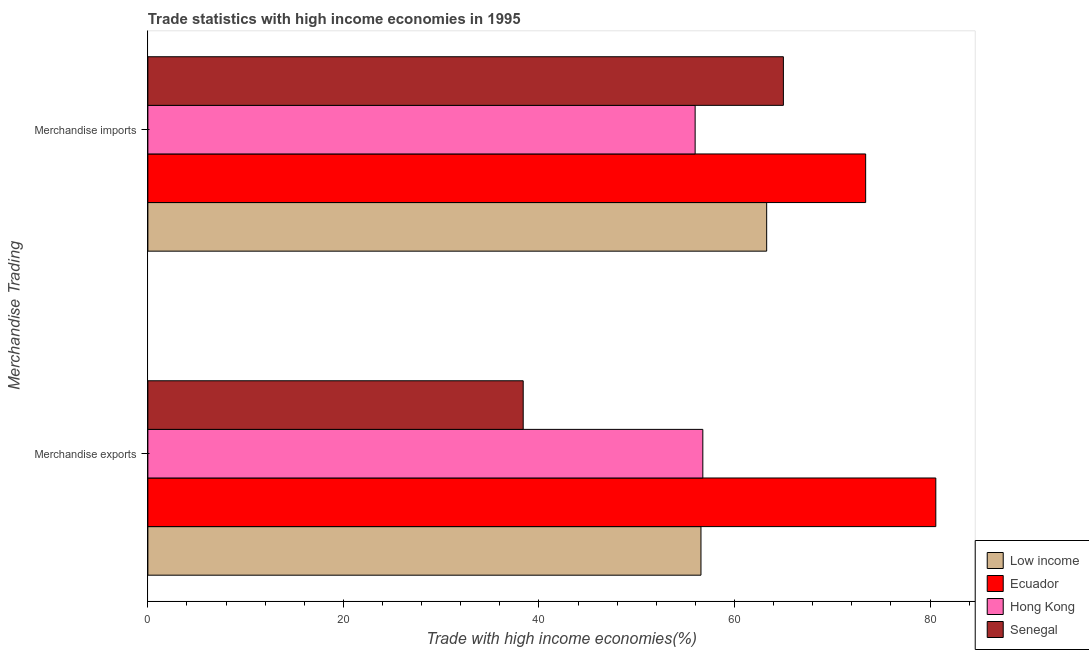How many different coloured bars are there?
Provide a succinct answer. 4. Are the number of bars on each tick of the Y-axis equal?
Keep it short and to the point. Yes. How many bars are there on the 1st tick from the top?
Provide a short and direct response. 4. What is the label of the 2nd group of bars from the top?
Your answer should be very brief. Merchandise exports. What is the merchandise exports in Low income?
Keep it short and to the point. 56.57. Across all countries, what is the maximum merchandise exports?
Offer a terse response. 80.58. Across all countries, what is the minimum merchandise exports?
Keep it short and to the point. 38.39. In which country was the merchandise imports maximum?
Offer a terse response. Ecuador. In which country was the merchandise imports minimum?
Keep it short and to the point. Hong Kong. What is the total merchandise imports in the graph?
Your answer should be compact. 257.66. What is the difference between the merchandise imports in Ecuador and that in Senegal?
Offer a very short reply. 8.41. What is the difference between the merchandise imports in Senegal and the merchandise exports in Ecuador?
Provide a short and direct response. -15.59. What is the average merchandise imports per country?
Your response must be concise. 64.42. What is the difference between the merchandise imports and merchandise exports in Ecuador?
Provide a short and direct response. -7.17. In how many countries, is the merchandise imports greater than 52 %?
Offer a terse response. 4. What is the ratio of the merchandise imports in Hong Kong to that in Low income?
Offer a terse response. 0.88. What does the 2nd bar from the top in Merchandise imports represents?
Offer a very short reply. Hong Kong. What does the 4th bar from the bottom in Merchandise imports represents?
Make the answer very short. Senegal. Are all the bars in the graph horizontal?
Your answer should be compact. Yes. What is the difference between two consecutive major ticks on the X-axis?
Provide a short and direct response. 20. Does the graph contain any zero values?
Offer a very short reply. No. Where does the legend appear in the graph?
Offer a terse response. Bottom right. How many legend labels are there?
Keep it short and to the point. 4. What is the title of the graph?
Provide a succinct answer. Trade statistics with high income economies in 1995. What is the label or title of the X-axis?
Your response must be concise. Trade with high income economies(%). What is the label or title of the Y-axis?
Offer a terse response. Merchandise Trading. What is the Trade with high income economies(%) in Low income in Merchandise exports?
Your response must be concise. 56.57. What is the Trade with high income economies(%) of Ecuador in Merchandise exports?
Your response must be concise. 80.58. What is the Trade with high income economies(%) of Hong Kong in Merchandise exports?
Offer a very short reply. 56.76. What is the Trade with high income economies(%) in Senegal in Merchandise exports?
Ensure brevity in your answer.  38.39. What is the Trade with high income economies(%) of Low income in Merchandise imports?
Your answer should be compact. 63.29. What is the Trade with high income economies(%) of Ecuador in Merchandise imports?
Your answer should be very brief. 73.41. What is the Trade with high income economies(%) of Hong Kong in Merchandise imports?
Provide a succinct answer. 55.97. What is the Trade with high income economies(%) in Senegal in Merchandise imports?
Keep it short and to the point. 65. Across all Merchandise Trading, what is the maximum Trade with high income economies(%) of Low income?
Offer a terse response. 63.29. Across all Merchandise Trading, what is the maximum Trade with high income economies(%) in Ecuador?
Make the answer very short. 80.58. Across all Merchandise Trading, what is the maximum Trade with high income economies(%) of Hong Kong?
Ensure brevity in your answer.  56.76. Across all Merchandise Trading, what is the maximum Trade with high income economies(%) of Senegal?
Provide a succinct answer. 65. Across all Merchandise Trading, what is the minimum Trade with high income economies(%) of Low income?
Give a very brief answer. 56.57. Across all Merchandise Trading, what is the minimum Trade with high income economies(%) in Ecuador?
Offer a very short reply. 73.41. Across all Merchandise Trading, what is the minimum Trade with high income economies(%) of Hong Kong?
Your answer should be compact. 55.97. Across all Merchandise Trading, what is the minimum Trade with high income economies(%) in Senegal?
Provide a short and direct response. 38.39. What is the total Trade with high income economies(%) of Low income in the graph?
Give a very brief answer. 119.85. What is the total Trade with high income economies(%) of Ecuador in the graph?
Provide a succinct answer. 153.99. What is the total Trade with high income economies(%) in Hong Kong in the graph?
Offer a very short reply. 112.73. What is the total Trade with high income economies(%) of Senegal in the graph?
Your answer should be very brief. 103.38. What is the difference between the Trade with high income economies(%) of Low income in Merchandise exports and that in Merchandise imports?
Keep it short and to the point. -6.72. What is the difference between the Trade with high income economies(%) in Ecuador in Merchandise exports and that in Merchandise imports?
Offer a very short reply. 7.17. What is the difference between the Trade with high income economies(%) of Hong Kong in Merchandise exports and that in Merchandise imports?
Keep it short and to the point. 0.79. What is the difference between the Trade with high income economies(%) in Senegal in Merchandise exports and that in Merchandise imports?
Offer a very short reply. -26.61. What is the difference between the Trade with high income economies(%) in Low income in Merchandise exports and the Trade with high income economies(%) in Ecuador in Merchandise imports?
Keep it short and to the point. -16.84. What is the difference between the Trade with high income economies(%) in Low income in Merchandise exports and the Trade with high income economies(%) in Hong Kong in Merchandise imports?
Provide a short and direct response. 0.6. What is the difference between the Trade with high income economies(%) in Low income in Merchandise exports and the Trade with high income economies(%) in Senegal in Merchandise imports?
Ensure brevity in your answer.  -8.43. What is the difference between the Trade with high income economies(%) of Ecuador in Merchandise exports and the Trade with high income economies(%) of Hong Kong in Merchandise imports?
Your answer should be compact. 24.61. What is the difference between the Trade with high income economies(%) of Ecuador in Merchandise exports and the Trade with high income economies(%) of Senegal in Merchandise imports?
Provide a short and direct response. 15.59. What is the difference between the Trade with high income economies(%) in Hong Kong in Merchandise exports and the Trade with high income economies(%) in Senegal in Merchandise imports?
Offer a very short reply. -8.24. What is the average Trade with high income economies(%) in Low income per Merchandise Trading?
Provide a short and direct response. 59.93. What is the average Trade with high income economies(%) of Ecuador per Merchandise Trading?
Ensure brevity in your answer.  77. What is the average Trade with high income economies(%) of Hong Kong per Merchandise Trading?
Your answer should be very brief. 56.36. What is the average Trade with high income economies(%) in Senegal per Merchandise Trading?
Provide a short and direct response. 51.69. What is the difference between the Trade with high income economies(%) of Low income and Trade with high income economies(%) of Ecuador in Merchandise exports?
Offer a terse response. -24.02. What is the difference between the Trade with high income economies(%) in Low income and Trade with high income economies(%) in Hong Kong in Merchandise exports?
Provide a succinct answer. -0.19. What is the difference between the Trade with high income economies(%) of Low income and Trade with high income economies(%) of Senegal in Merchandise exports?
Provide a short and direct response. 18.18. What is the difference between the Trade with high income economies(%) of Ecuador and Trade with high income economies(%) of Hong Kong in Merchandise exports?
Provide a short and direct response. 23.83. What is the difference between the Trade with high income economies(%) in Ecuador and Trade with high income economies(%) in Senegal in Merchandise exports?
Give a very brief answer. 42.2. What is the difference between the Trade with high income economies(%) in Hong Kong and Trade with high income economies(%) in Senegal in Merchandise exports?
Your answer should be compact. 18.37. What is the difference between the Trade with high income economies(%) of Low income and Trade with high income economies(%) of Ecuador in Merchandise imports?
Keep it short and to the point. -10.12. What is the difference between the Trade with high income economies(%) in Low income and Trade with high income economies(%) in Hong Kong in Merchandise imports?
Provide a succinct answer. 7.32. What is the difference between the Trade with high income economies(%) of Low income and Trade with high income economies(%) of Senegal in Merchandise imports?
Offer a terse response. -1.71. What is the difference between the Trade with high income economies(%) of Ecuador and Trade with high income economies(%) of Hong Kong in Merchandise imports?
Provide a succinct answer. 17.44. What is the difference between the Trade with high income economies(%) of Ecuador and Trade with high income economies(%) of Senegal in Merchandise imports?
Your answer should be compact. 8.41. What is the difference between the Trade with high income economies(%) of Hong Kong and Trade with high income economies(%) of Senegal in Merchandise imports?
Your answer should be compact. -9.03. What is the ratio of the Trade with high income economies(%) of Low income in Merchandise exports to that in Merchandise imports?
Your response must be concise. 0.89. What is the ratio of the Trade with high income economies(%) in Ecuador in Merchandise exports to that in Merchandise imports?
Your response must be concise. 1.1. What is the ratio of the Trade with high income economies(%) of Hong Kong in Merchandise exports to that in Merchandise imports?
Give a very brief answer. 1.01. What is the ratio of the Trade with high income economies(%) in Senegal in Merchandise exports to that in Merchandise imports?
Your answer should be very brief. 0.59. What is the difference between the highest and the second highest Trade with high income economies(%) of Low income?
Make the answer very short. 6.72. What is the difference between the highest and the second highest Trade with high income economies(%) in Ecuador?
Provide a short and direct response. 7.17. What is the difference between the highest and the second highest Trade with high income economies(%) in Hong Kong?
Offer a terse response. 0.79. What is the difference between the highest and the second highest Trade with high income economies(%) of Senegal?
Your response must be concise. 26.61. What is the difference between the highest and the lowest Trade with high income economies(%) in Low income?
Your response must be concise. 6.72. What is the difference between the highest and the lowest Trade with high income economies(%) in Ecuador?
Offer a terse response. 7.17. What is the difference between the highest and the lowest Trade with high income economies(%) of Hong Kong?
Make the answer very short. 0.79. What is the difference between the highest and the lowest Trade with high income economies(%) of Senegal?
Provide a short and direct response. 26.61. 